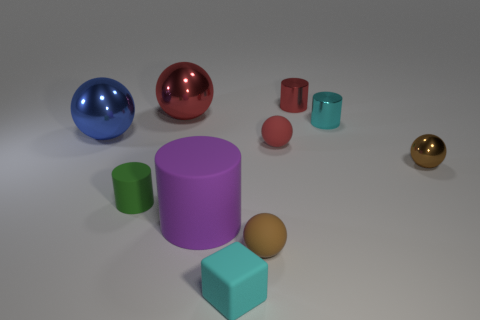Subtract all blue balls. How many balls are left? 4 Subtract all large blue metal spheres. How many spheres are left? 4 Subtract all purple cubes. Subtract all cyan balls. How many cubes are left? 1 Subtract all cylinders. How many objects are left? 6 Subtract 0 brown cylinders. How many objects are left? 10 Subtract all large purple rubber things. Subtract all blue spheres. How many objects are left? 8 Add 1 tiny blocks. How many tiny blocks are left? 2 Add 6 green rubber cylinders. How many green rubber cylinders exist? 7 